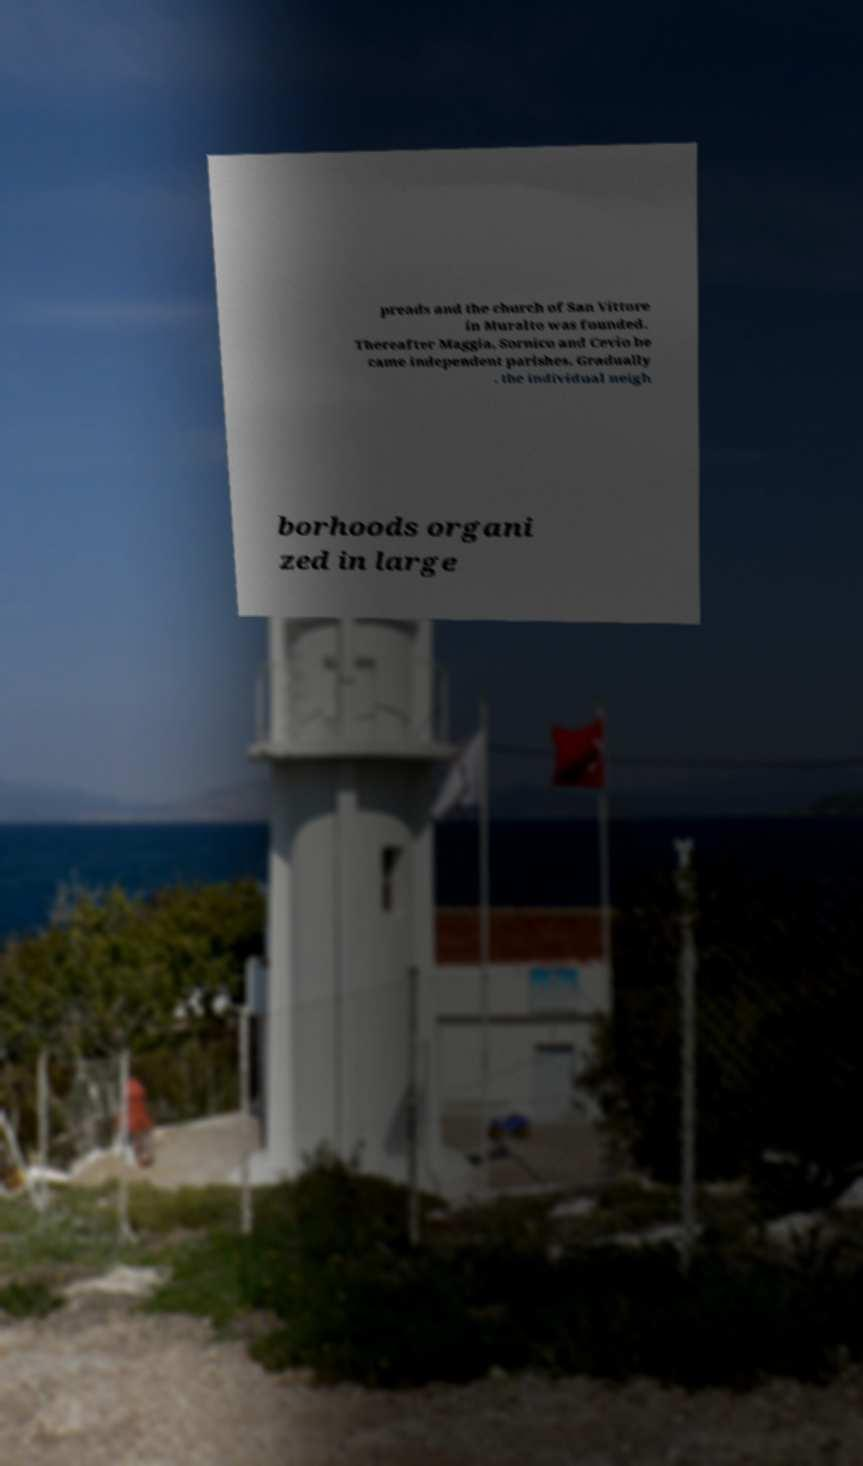Could you assist in decoding the text presented in this image and type it out clearly? preads and the church of San Vittore in Muralto was founded. Thereafter Maggia, Sornico and Cevio be came independent parishes. Gradually , the individual neigh borhoods organi zed in large 